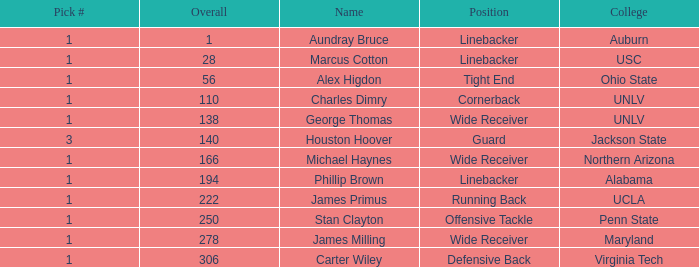In what Round with an Overall greater than 306 was the pick from the College of Virginia Tech? 0.0. 